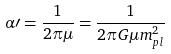<formula> <loc_0><loc_0><loc_500><loc_500>\alpha \prime = \frac { 1 } { 2 \pi \mu } = \frac { 1 } { 2 \pi G \mu m ^ { 2 } _ { p l } }</formula> 